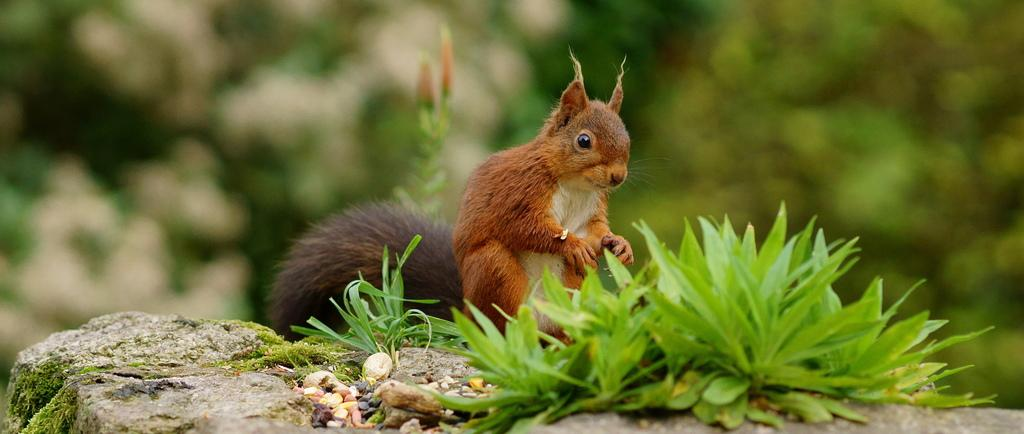What type of vegetation is present in the image? There is grass in the image. What other object can be seen in the image? There is a stone in the image. What living creature is in the image? There is an animal in the image. What can be seen in the distance in the image? There are trees in the background of the image. How many chickens are attempting to eat the berry in the image? There are no chickens or berries present in the image. 